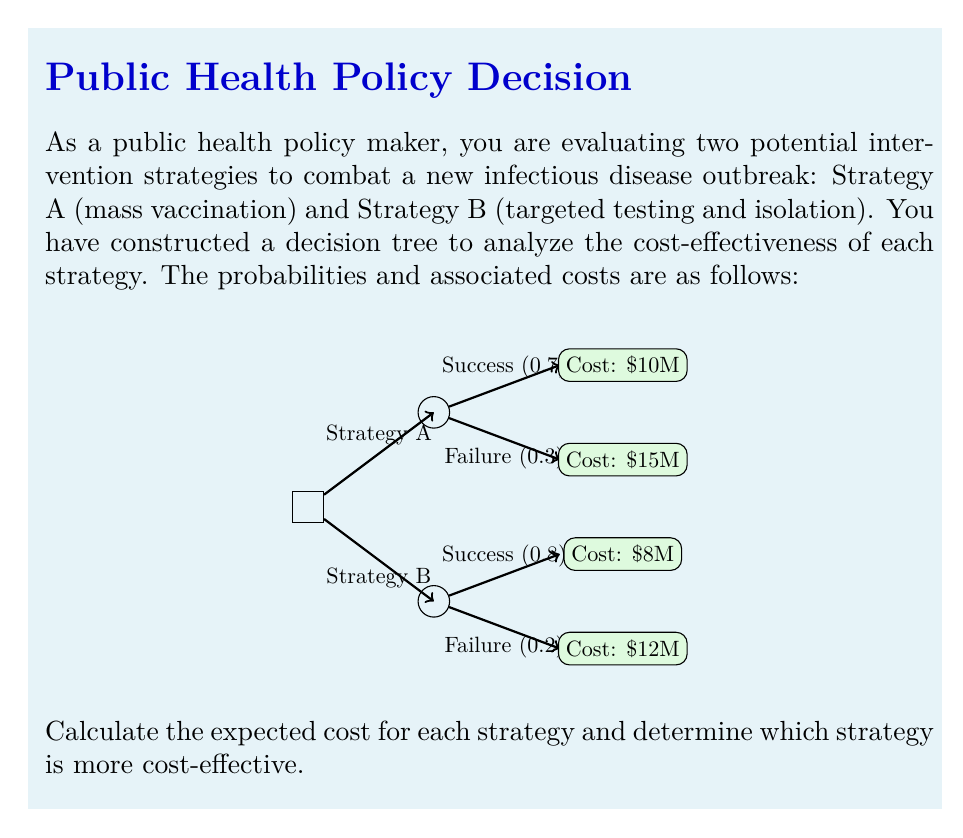Provide a solution to this math problem. To solve this problem, we need to calculate the expected cost for each strategy using the decision tree analysis. Let's go through it step-by-step:

1. Strategy A (Mass Vaccination):
   - Probability of success: 0.7
   - Probability of failure: 0.3
   - Cost if successful: $10 million
   - Cost if failed: $15 million

   Expected cost for Strategy A:
   $$E(A) = 0.7 \times 10 + 0.3 \times 15 = 7 + 4.5 = 11.5$$ million

2. Strategy B (Targeted Testing and Isolation):
   - Probability of success: 0.8
   - Probability of failure: 0.2
   - Cost if successful: $8 million
   - Cost if failed: $12 million

   Expected cost for Strategy B:
   $$E(B) = 0.8 \times 8 + 0.2 \times 12 = 6.4 + 2.4 = 8.8$$ million

3. Comparing the expected costs:
   Strategy A: $11.5 million
   Strategy B: $8.8 million

   The difference in expected costs:
   $$11.5 - 8.8 = 2.7$$ million

4. Conclusion:
   Strategy B (Targeted Testing and Isolation) has a lower expected cost of $8.8 million compared to Strategy A (Mass Vaccination) with an expected cost of $11.5 million. Therefore, Strategy B is more cost-effective by $2.7 million.
Answer: Strategy B (Targeted Testing and Isolation) is more cost-effective, saving $2.7 million in expected costs. 